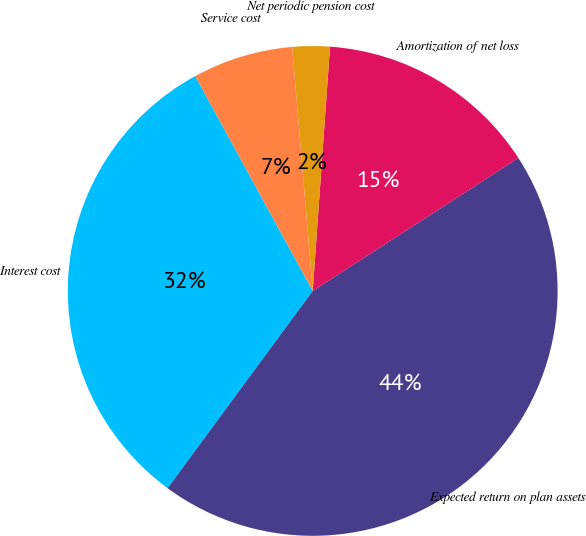<chart> <loc_0><loc_0><loc_500><loc_500><pie_chart><fcel>Interest cost<fcel>Expected return on plan assets<fcel>Amortization of net loss<fcel>Net periodic pension cost<fcel>Service cost<nl><fcel>31.94%<fcel>44.23%<fcel>14.74%<fcel>2.46%<fcel>6.63%<nl></chart> 